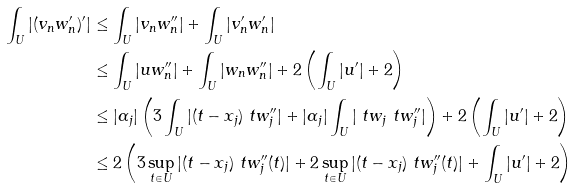<formula> <loc_0><loc_0><loc_500><loc_500>\int _ { U } | ( v _ { n } w _ { n } ^ { \prime } ) ^ { \prime } | & \leq \int _ { U } | v _ { n } w _ { n } ^ { \prime \prime } | + \int _ { U } | v _ { n } ^ { \prime } w _ { n } ^ { \prime } | \\ & \leq \int _ { U } | u w _ { n } ^ { \prime \prime } | + \int _ { U } | w _ { n } w _ { n } ^ { \prime \prime } | + 2 \left ( \int _ { U } | u ^ { \prime } | + 2 \right ) \\ & \leq | \alpha _ { j } | \left ( 3 \int _ { U } | ( t - x _ { j } ) \ t w _ { j } ^ { \prime \prime } | + | \alpha _ { j } | \int _ { U } | \ t w _ { j } \ t w _ { j } ^ { \prime \prime } | \right ) + 2 \left ( \int _ { U } | u ^ { \prime } | + 2 \right ) \\ & \leq 2 \left ( 3 \sup _ { t \in U } | ( t - x _ { j } ) \ t w _ { j } ^ { \prime \prime } ( t ) | + 2 \sup _ { t \in U } | ( t - x _ { j } ) \ t w _ { j } ^ { \prime \prime } ( t ) | + \int _ { U } | u ^ { \prime } | + 2 \right )</formula> 